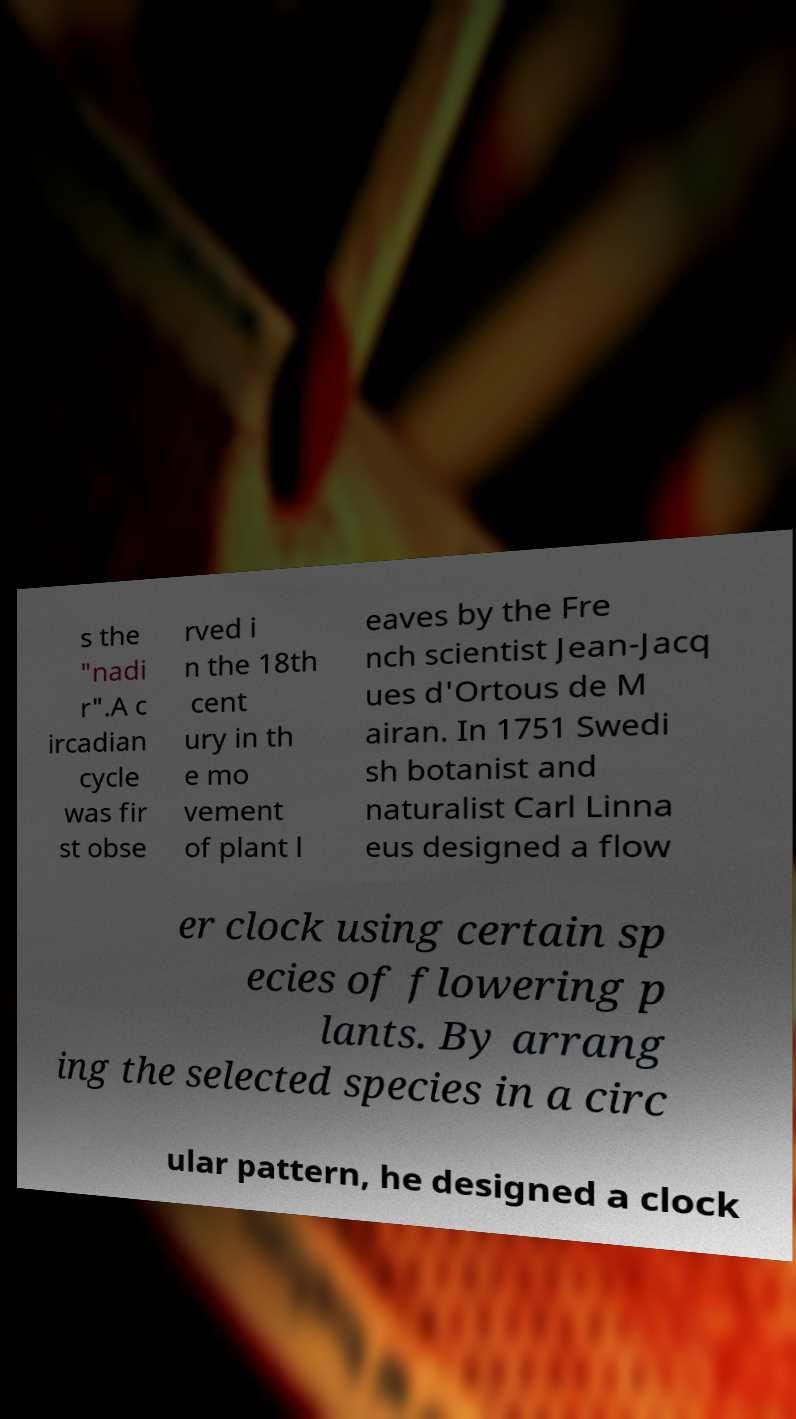Can you accurately transcribe the text from the provided image for me? s the "nadi r".A c ircadian cycle was fir st obse rved i n the 18th cent ury in th e mo vement of plant l eaves by the Fre nch scientist Jean-Jacq ues d'Ortous de M airan. In 1751 Swedi sh botanist and naturalist Carl Linna eus designed a flow er clock using certain sp ecies of flowering p lants. By arrang ing the selected species in a circ ular pattern, he designed a clock 